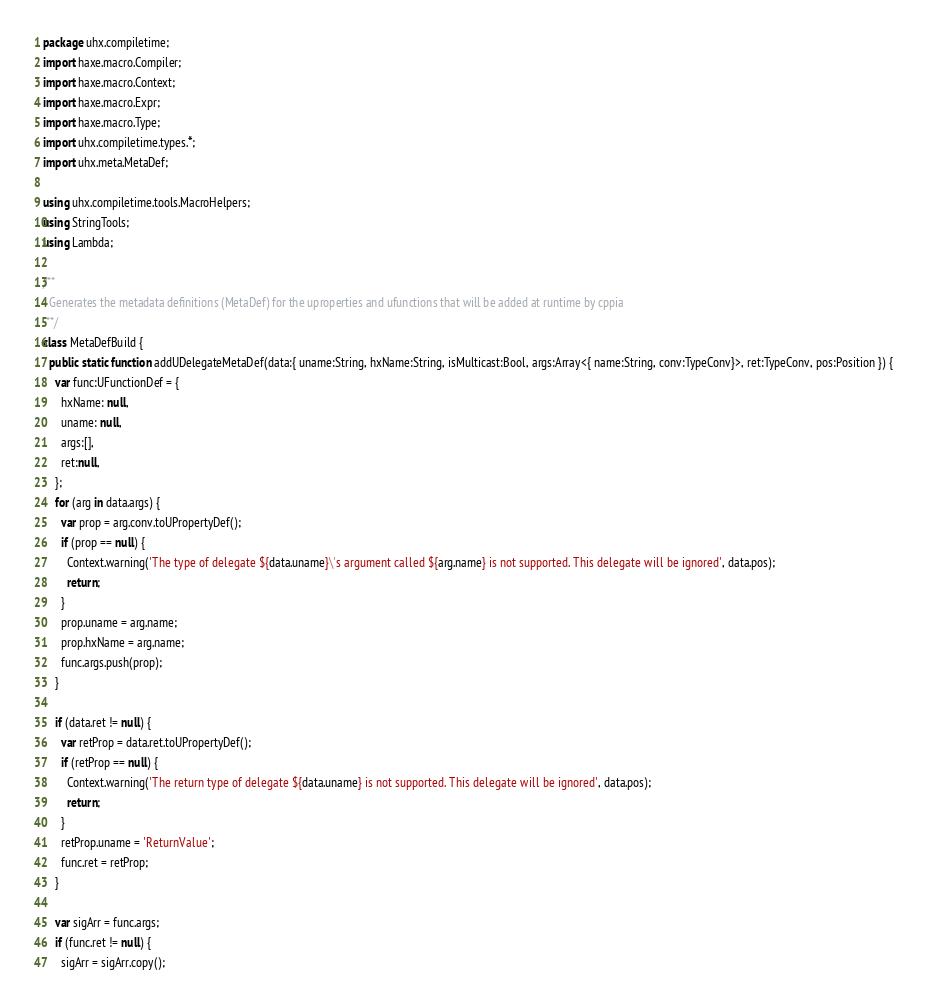Convert code to text. <code><loc_0><loc_0><loc_500><loc_500><_Haxe_>package uhx.compiletime;
import haxe.macro.Compiler;
import haxe.macro.Context;
import haxe.macro.Expr;
import haxe.macro.Type;
import uhx.compiletime.types.*;
import uhx.meta.MetaDef;

using uhx.compiletime.tools.MacroHelpers;
using StringTools;
using Lambda;

/**
  Generates the metadata definitions (MetaDef) for the uproperties and ufunctions that will be added at runtime by cppia
 **/
class MetaDefBuild {
  public static function addUDelegateMetaDef(data:{ uname:String, hxName:String, isMulticast:Bool, args:Array<{ name:String, conv:TypeConv}>, ret:TypeConv, pos:Position }) {
    var func:UFunctionDef = {
      hxName: null,
      uname: null,
      args:[],
      ret:null,
    };
    for (arg in data.args) {
      var prop = arg.conv.toUPropertyDef();
      if (prop == null) {
        Context.warning('The type of delegate ${data.uname}\'s argument called ${arg.name} is not supported. This delegate will be ignored', data.pos);
        return;
      }
      prop.uname = arg.name;
      prop.hxName = arg.name;
      func.args.push(prop);
    }

    if (data.ret != null) {
      var retProp = data.ret.toUPropertyDef();
      if (retProp == null) {
        Context.warning('The return type of delegate ${data.uname} is not supported. This delegate will be ignored', data.pos);
        return;
      }
      retProp.uname = 'ReturnValue';
      func.ret = retProp;
    }

    var sigArr = func.args;
    if (func.ret != null) {
      sigArr = sigArr.copy();</code> 